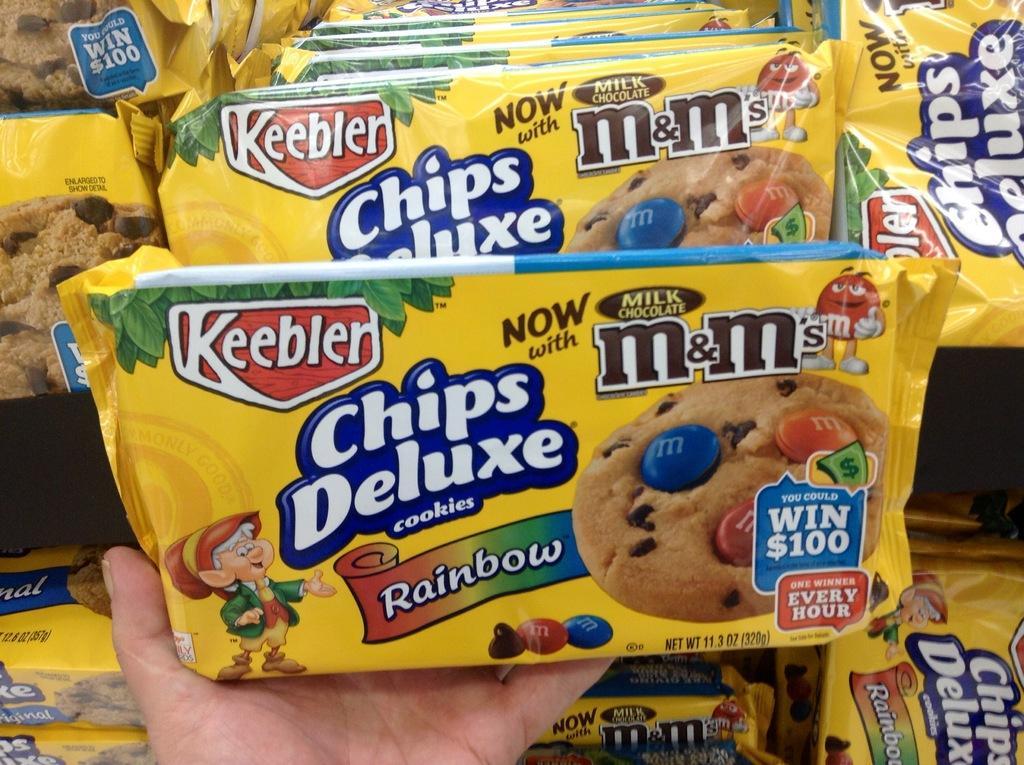In one or two sentences, can you explain what this image depicts? In this image we can see a biscuit packet in the person's hand, there we can see few biscuit packets in racks. 